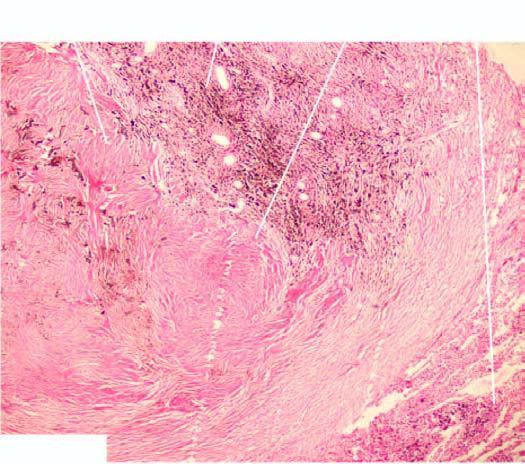what are coal macules composed of?
Answer the question using a single word or phrase. Aggregates of dust-laden macrophages and collagens are seen surrounding respiratory bronchioles 